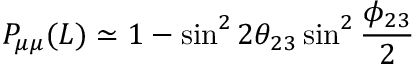<formula> <loc_0><loc_0><loc_500><loc_500>P _ { \mu \mu } ( L ) \simeq 1 - \sin ^ { 2 } 2 \theta _ { 2 3 } \sin ^ { 2 } \frac { \phi _ { 2 3 } } { 2 }</formula> 